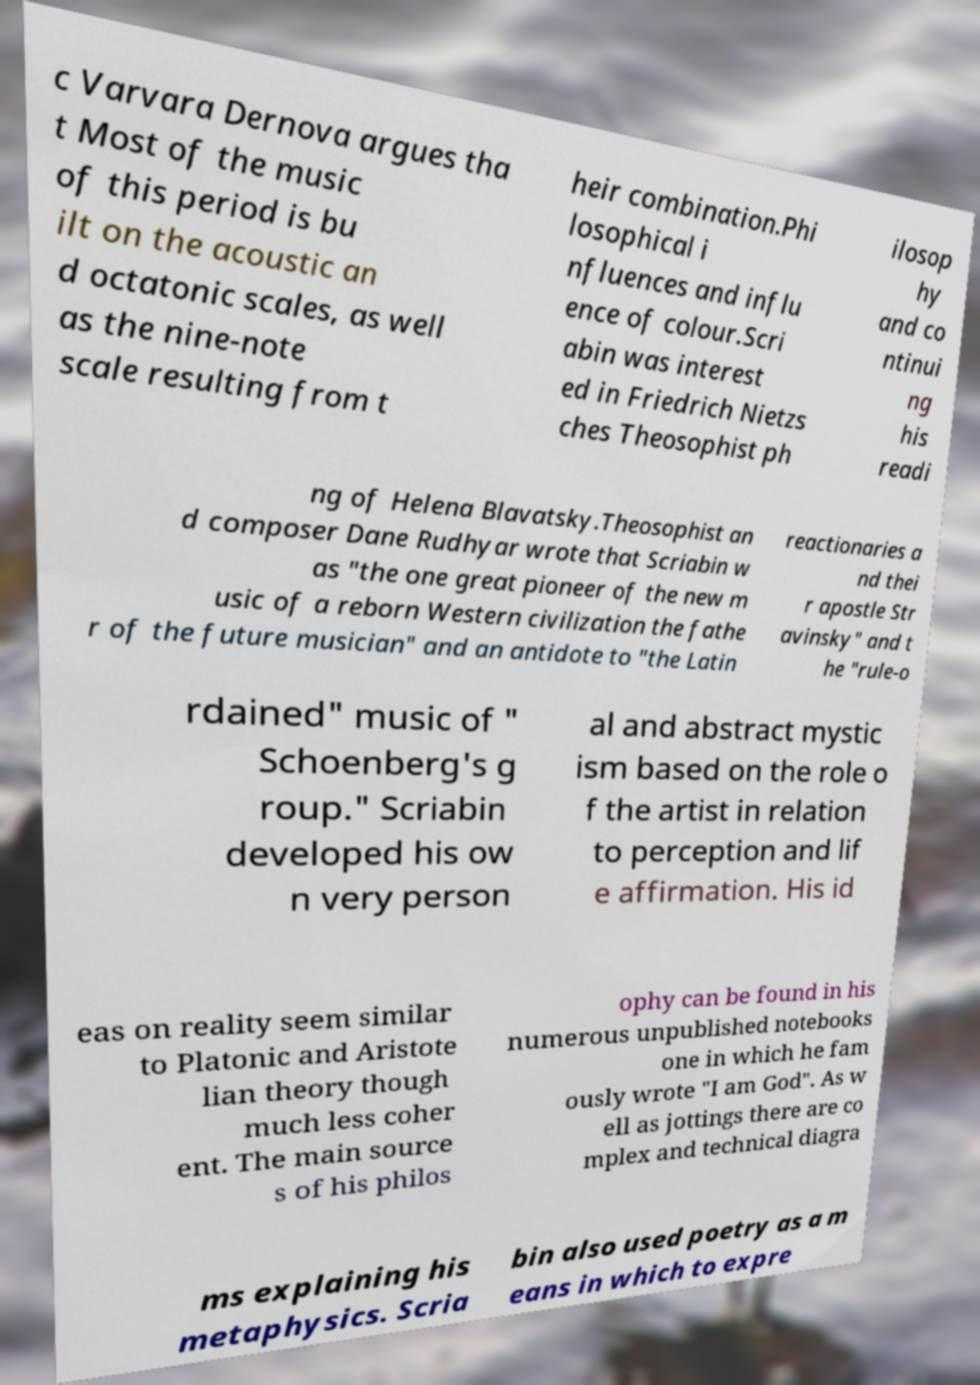Could you assist in decoding the text presented in this image and type it out clearly? c Varvara Dernova argues tha t Most of the music of this period is bu ilt on the acoustic an d octatonic scales, as well as the nine-note scale resulting from t heir combination.Phi losophical i nfluences and influ ence of colour.Scri abin was interest ed in Friedrich Nietzs ches Theosophist ph ilosop hy and co ntinui ng his readi ng of Helena Blavatsky.Theosophist an d composer Dane Rudhyar wrote that Scriabin w as "the one great pioneer of the new m usic of a reborn Western civilization the fathe r of the future musician" and an antidote to "the Latin reactionaries a nd thei r apostle Str avinsky" and t he "rule-o rdained" music of " Schoenberg's g roup." Scriabin developed his ow n very person al and abstract mystic ism based on the role o f the artist in relation to perception and lif e affirmation. His id eas on reality seem similar to Platonic and Aristote lian theory though much less coher ent. The main source s of his philos ophy can be found in his numerous unpublished notebooks one in which he fam ously wrote "I am God". As w ell as jottings there are co mplex and technical diagra ms explaining his metaphysics. Scria bin also used poetry as a m eans in which to expre 